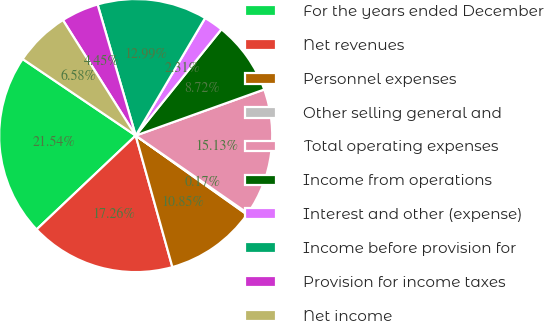Convert chart to OTSL. <chart><loc_0><loc_0><loc_500><loc_500><pie_chart><fcel>For the years ended December<fcel>Net revenues<fcel>Personnel expenses<fcel>Other selling general and<fcel>Total operating expenses<fcel>Income from operations<fcel>Interest and other (expense)<fcel>Income before provision for<fcel>Provision for income taxes<fcel>Net income<nl><fcel>21.54%<fcel>17.26%<fcel>10.85%<fcel>0.17%<fcel>15.13%<fcel>8.72%<fcel>2.31%<fcel>12.99%<fcel>4.45%<fcel>6.58%<nl></chart> 